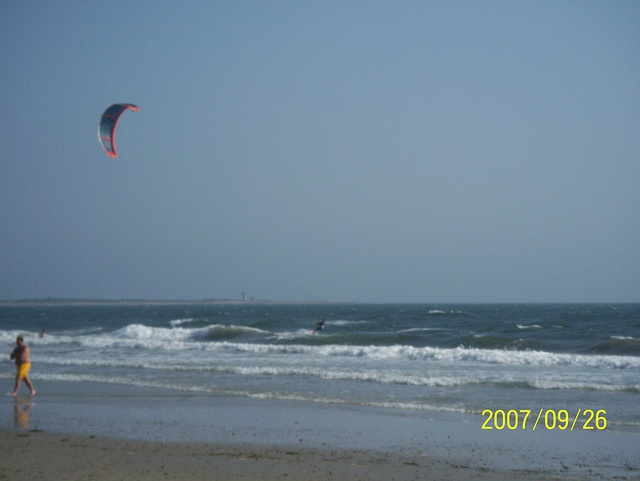Describe the objects in this image and their specific colors. I can see kite in gray and darkblue tones, people in gray, black, and maroon tones, and people in gray, blue, black, and darkblue tones in this image. 